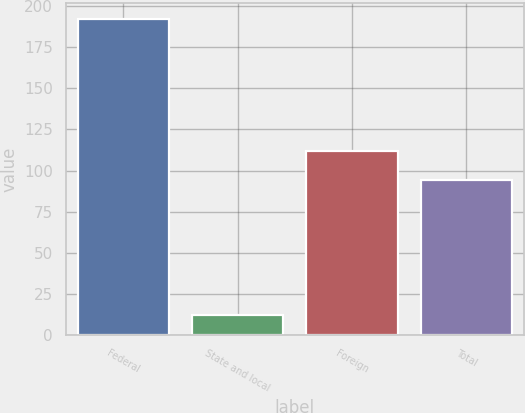<chart> <loc_0><loc_0><loc_500><loc_500><bar_chart><fcel>Federal<fcel>State and local<fcel>Foreign<fcel>Total<nl><fcel>192<fcel>12<fcel>112<fcel>94<nl></chart> 